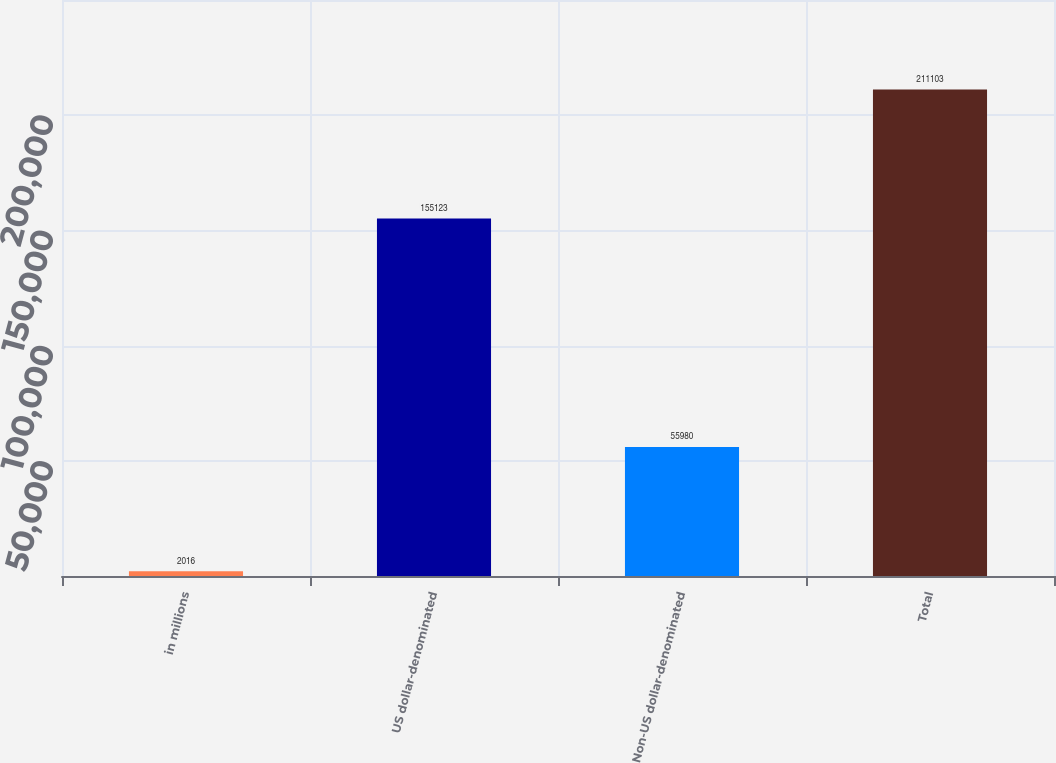Convert chart. <chart><loc_0><loc_0><loc_500><loc_500><bar_chart><fcel>in millions<fcel>US dollar-denominated<fcel>Non-US dollar-denominated<fcel>Total<nl><fcel>2016<fcel>155123<fcel>55980<fcel>211103<nl></chart> 